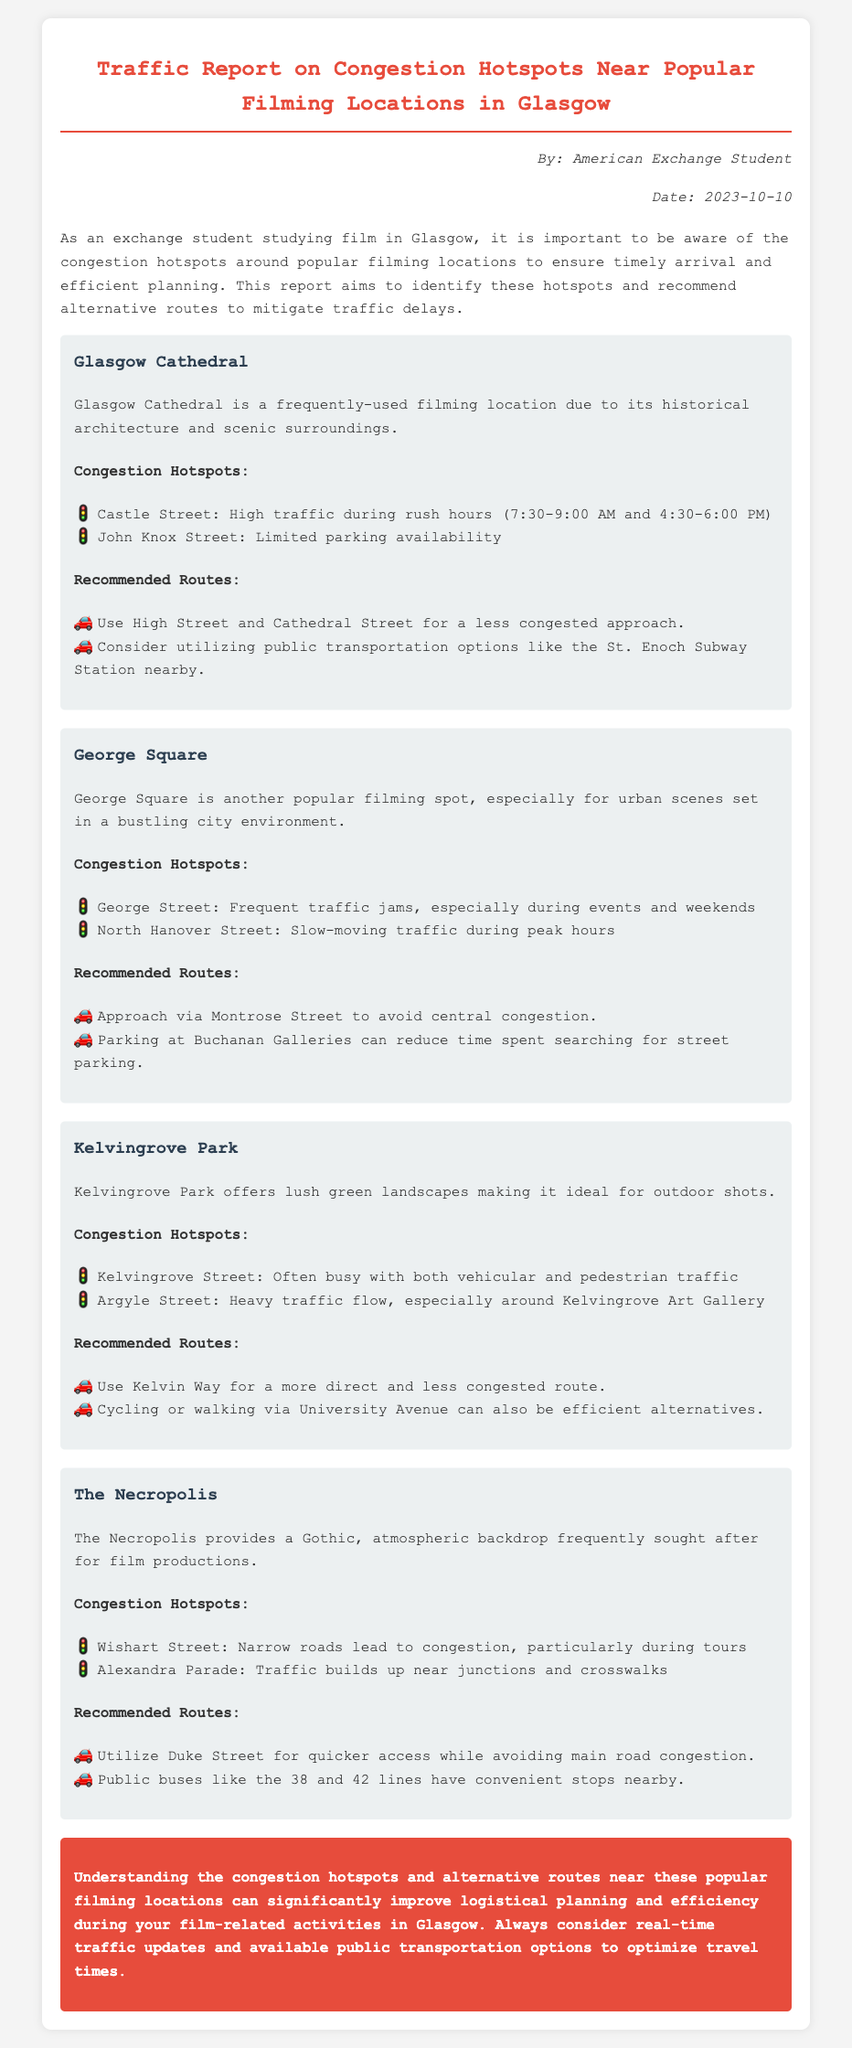What is the date of the report? The report is dated 2023-10-10, as stated in the author-date section.
Answer: 2023-10-10 Which location is described as ideal for outdoor shots? The report mentions Kelvingrove Park as ideal for outdoor shots.
Answer: Kelvingrove Park What are the recommended routes for Glasgow Cathedral? The document lists two recommended routes: High Street and Cathedral Street; and public transportation options like St. Enoch Subway Station.
Answer: Use High Street and Cathedral Street; consider utilizing public transportation options like the St. Enoch Subway Station Which street has limited parking availability near Glasgow Cathedral? The report identifies John Knox Street as having limited parking availability.
Answer: John Knox Street What is the peak hour for congestion on Castle Street? The document specifies that peak congestion occurs during the hours of 7:30 to 9:00 AM.
Answer: 7:30-9:00 AM What alternative route is suggested to avoid congestion near George Square? The report recommends approaching via Montrose Street to avoid central congestion.
Answer: Montrose Street Which location has heavy traffic flow around Kelvingrove Art Gallery? The report states that Argyle Street has heavy traffic flow around Kelvingrove Art Gallery.
Answer: Argyle Street How does The Necropolis contribute to film productions? The report describes The Necropolis as providing a Gothic, atmospheric backdrop frequently sought after for film productions.
Answer: Gothic, atmospheric backdrop What time frame is considered rush hour according to the report? The document specifically mentions 7:30-9:00 AM and 4:30-6:00 PM as rush hour time frames.
Answer: 7:30-9:00 AM and 4:30-6:00 PM 